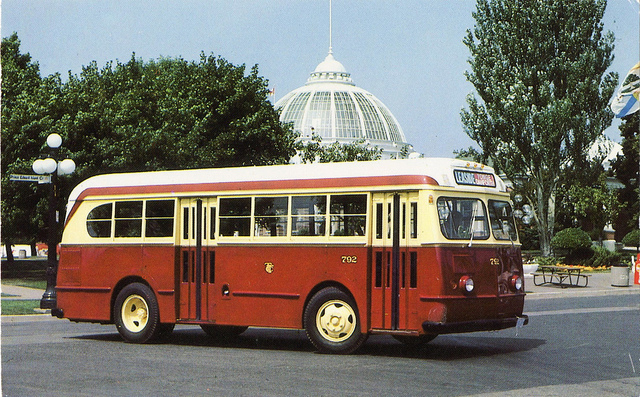Identify the text displayed in this image. 72 292 